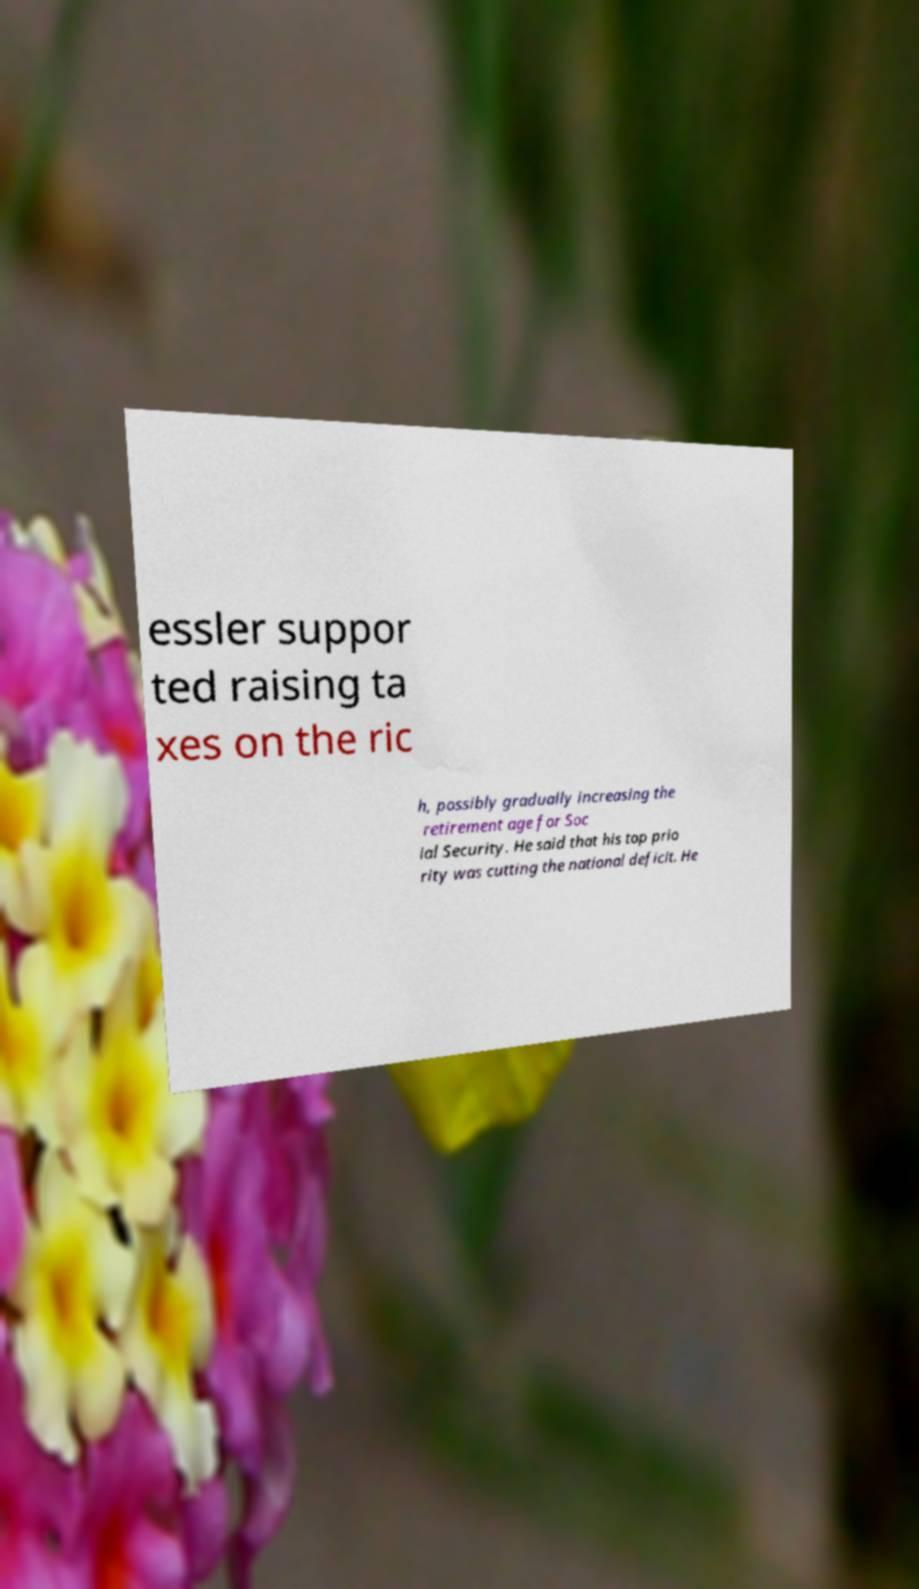I need the written content from this picture converted into text. Can you do that? essler suppor ted raising ta xes on the ric h, possibly gradually increasing the retirement age for Soc ial Security. He said that his top prio rity was cutting the national deficit. He 